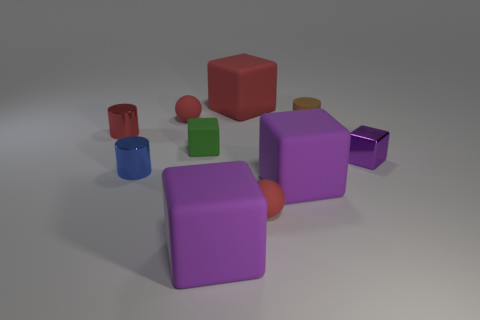Subtract all yellow cylinders. How many purple cubes are left? 3 Subtract all red blocks. How many blocks are left? 4 Subtract all purple shiny cubes. How many cubes are left? 4 Subtract 1 blocks. How many blocks are left? 4 Subtract all blue cubes. Subtract all green balls. How many cubes are left? 5 Subtract all balls. How many objects are left? 8 Add 2 small cylinders. How many small cylinders are left? 5 Add 2 brown rubber things. How many brown rubber things exist? 3 Subtract 0 purple cylinders. How many objects are left? 10 Subtract all big blue rubber blocks. Subtract all rubber cylinders. How many objects are left? 9 